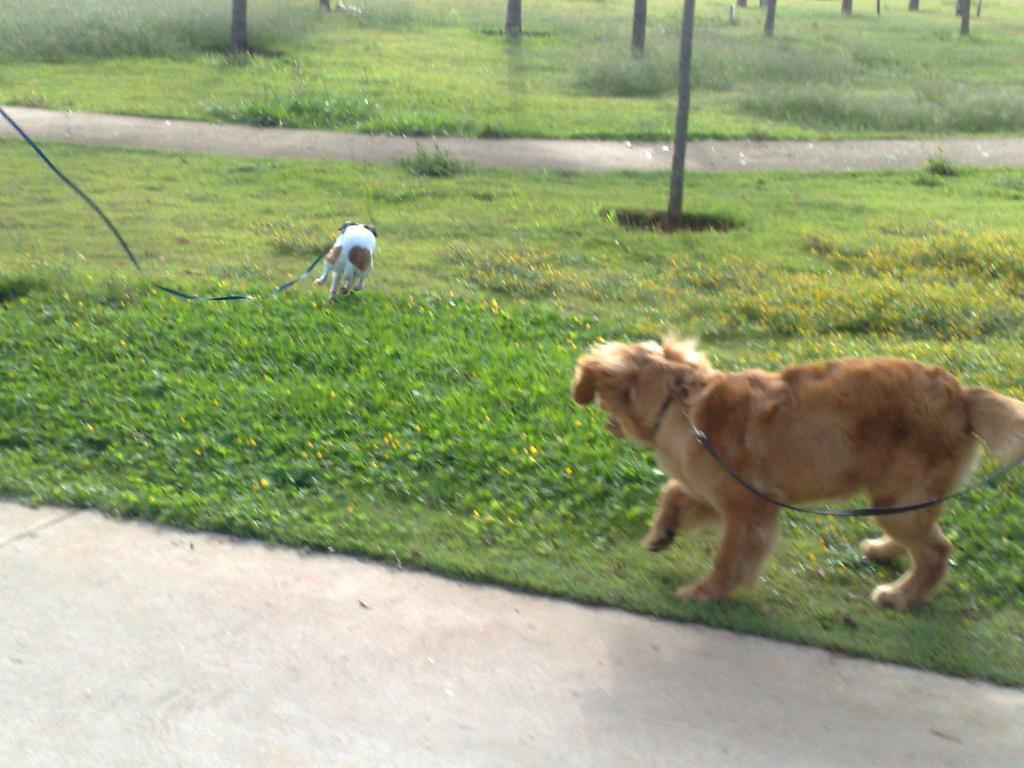Can you describe this image briefly? In this picture we can see couple of dogs on the grass and the dogs tied with belts, in the background we can see few plants. 